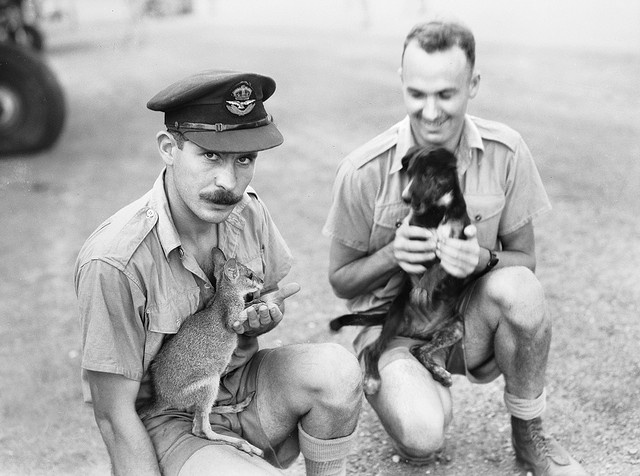Describe the objects in this image and their specific colors. I can see people in black, darkgray, lightgray, and gray tones, people in black, lightgray, darkgray, and gray tones, and dog in black, gray, darkgray, and gainsboro tones in this image. 